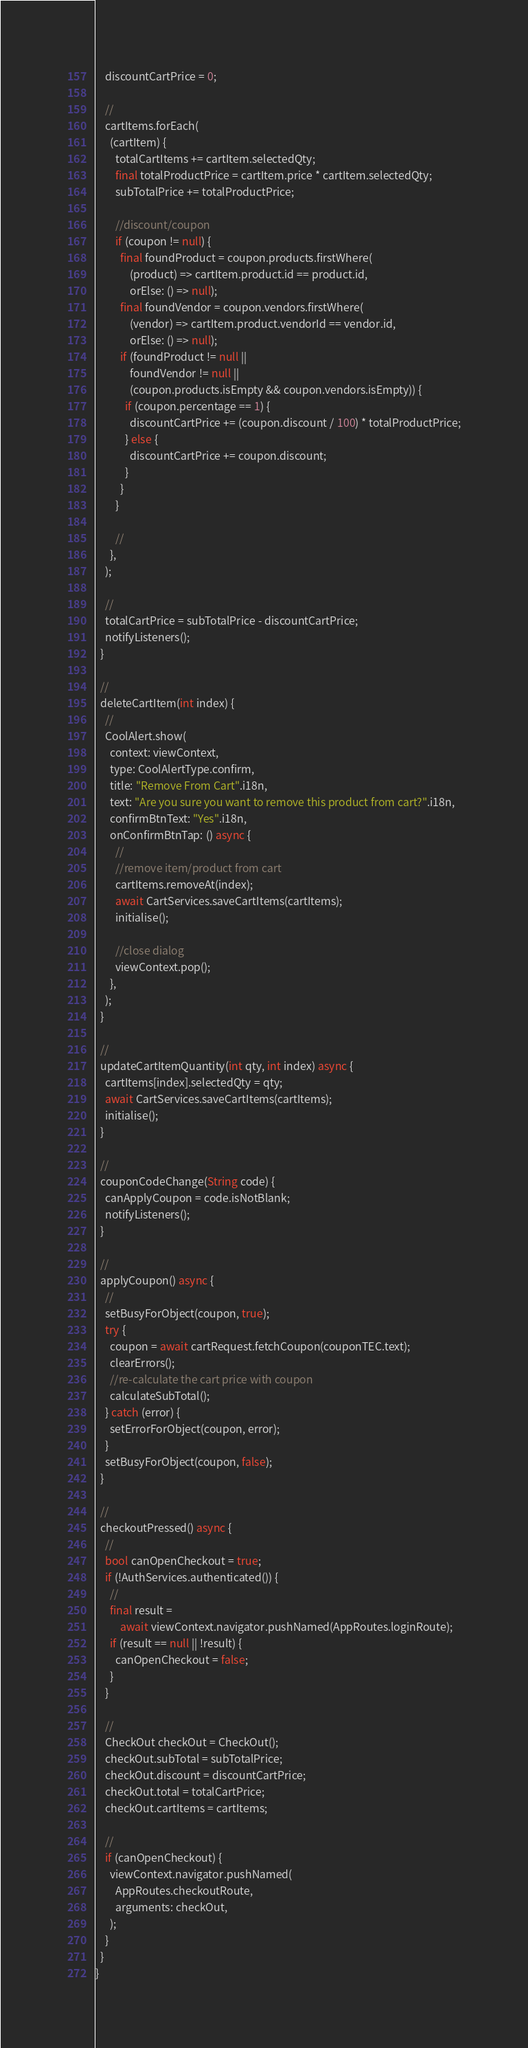Convert code to text. <code><loc_0><loc_0><loc_500><loc_500><_Dart_>    discountCartPrice = 0;

    //
    cartItems.forEach(
      (cartItem) {
        totalCartItems += cartItem.selectedQty;
        final totalProductPrice = cartItem.price * cartItem.selectedQty;
        subTotalPrice += totalProductPrice;

        //discount/coupon
        if (coupon != null) {
          final foundProduct = coupon.products.firstWhere(
              (product) => cartItem.product.id == product.id,
              orElse: () => null);
          final foundVendor = coupon.vendors.firstWhere(
              (vendor) => cartItem.product.vendorId == vendor.id,
              orElse: () => null);
          if (foundProduct != null ||
              foundVendor != null ||
              (coupon.products.isEmpty && coupon.vendors.isEmpty)) {
            if (coupon.percentage == 1) {
              discountCartPrice += (coupon.discount / 100) * totalProductPrice;
            } else {
              discountCartPrice += coupon.discount;
            }
          }
        }

        //
      },
    );

    //
    totalCartPrice = subTotalPrice - discountCartPrice;
    notifyListeners();
  }

  //
  deleteCartItem(int index) {
    //
    CoolAlert.show(
      context: viewContext,
      type: CoolAlertType.confirm,
      title: "Remove From Cart".i18n,
      text: "Are you sure you want to remove this product from cart?".i18n,
      confirmBtnText: "Yes".i18n,
      onConfirmBtnTap: () async {
        //
        //remove item/product from cart
        cartItems.removeAt(index);
        await CartServices.saveCartItems(cartItems);
        initialise();

        //close dialog
        viewContext.pop();
      },
    );
  }

  //
  updateCartItemQuantity(int qty, int index) async {
    cartItems[index].selectedQty = qty;
    await CartServices.saveCartItems(cartItems);
    initialise();
  }

  //
  couponCodeChange(String code) {
    canApplyCoupon = code.isNotBlank;
    notifyListeners();
  }

  //
  applyCoupon() async {
    //
    setBusyForObject(coupon, true);
    try {
      coupon = await cartRequest.fetchCoupon(couponTEC.text);
      clearErrors();
      //re-calculate the cart price with coupon
      calculateSubTotal();
    } catch (error) {
      setErrorForObject(coupon, error);
    }
    setBusyForObject(coupon, false);
  }

  //
  checkoutPressed() async {
    //
    bool canOpenCheckout = true;
    if (!AuthServices.authenticated()) {
      //
      final result =
          await viewContext.navigator.pushNamed(AppRoutes.loginRoute);
      if (result == null || !result) {
        canOpenCheckout = false;
      }
    }

    //
    CheckOut checkOut = CheckOut();
    checkOut.subTotal = subTotalPrice;
    checkOut.discount = discountCartPrice;
    checkOut.total = totalCartPrice;
    checkOut.cartItems = cartItems;

    //
    if (canOpenCheckout) {
      viewContext.navigator.pushNamed(
        AppRoutes.checkoutRoute,
        arguments: checkOut,
      );
    }
  }
}
</code> 